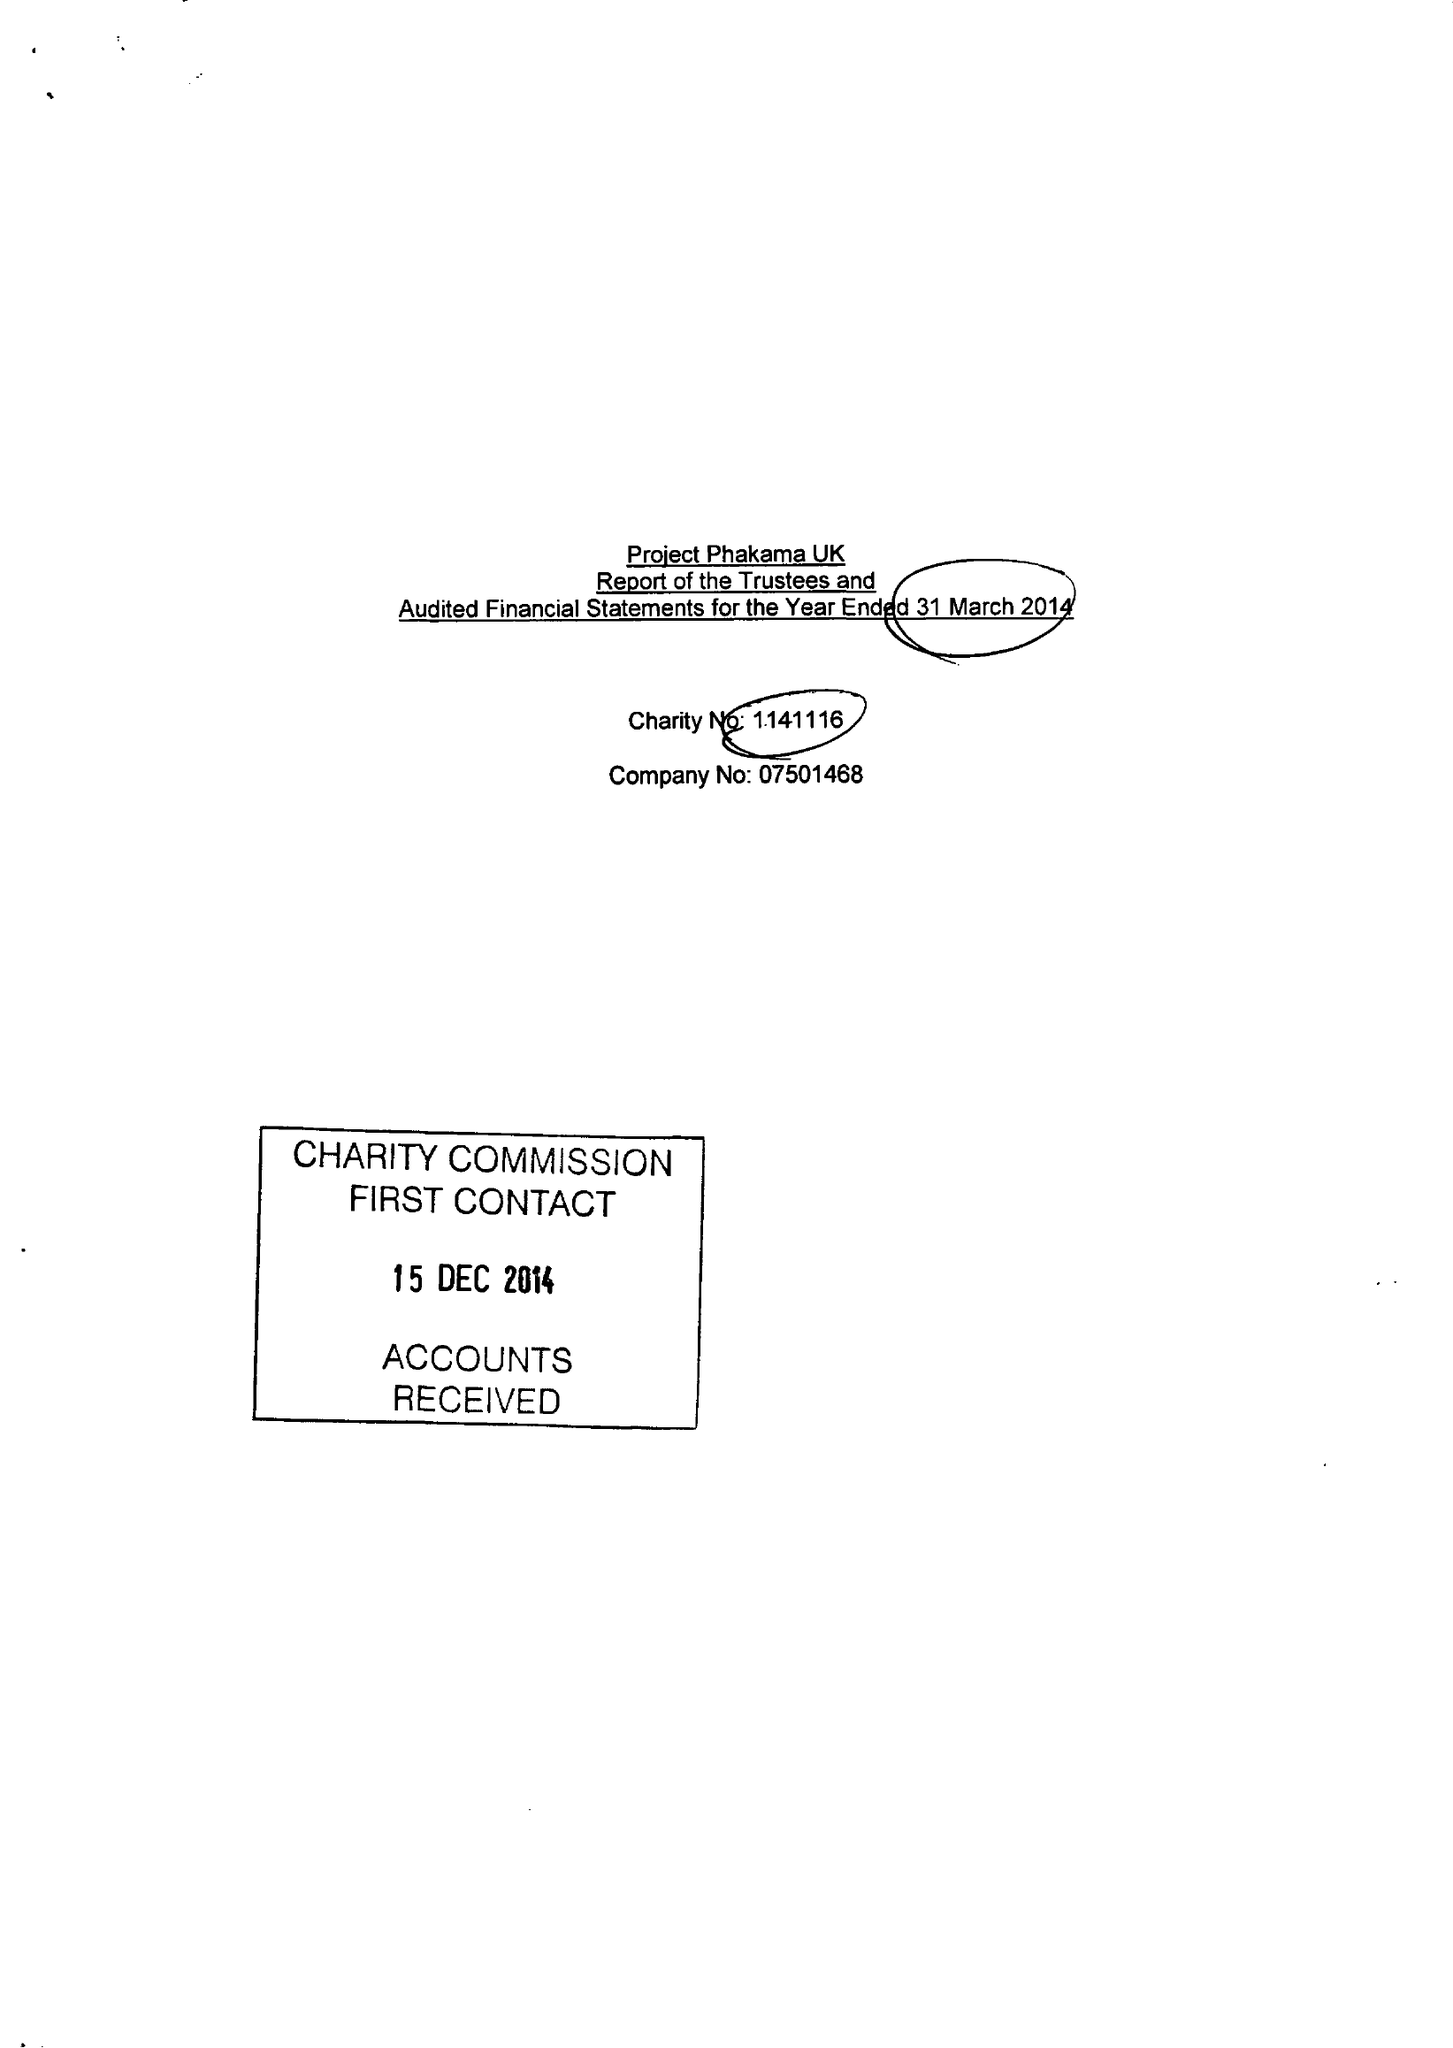What is the value for the income_annually_in_british_pounds?
Answer the question using a single word or phrase. 279696.00 